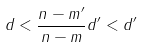<formula> <loc_0><loc_0><loc_500><loc_500>d < \frac { n - m ^ { \prime } } { n - m } d ^ { \prime } < d ^ { \prime }</formula> 